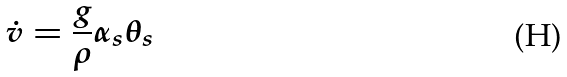<formula> <loc_0><loc_0><loc_500><loc_500>\dot { v } = \frac { g } { \rho } \alpha _ { s } \theta _ { s }</formula> 